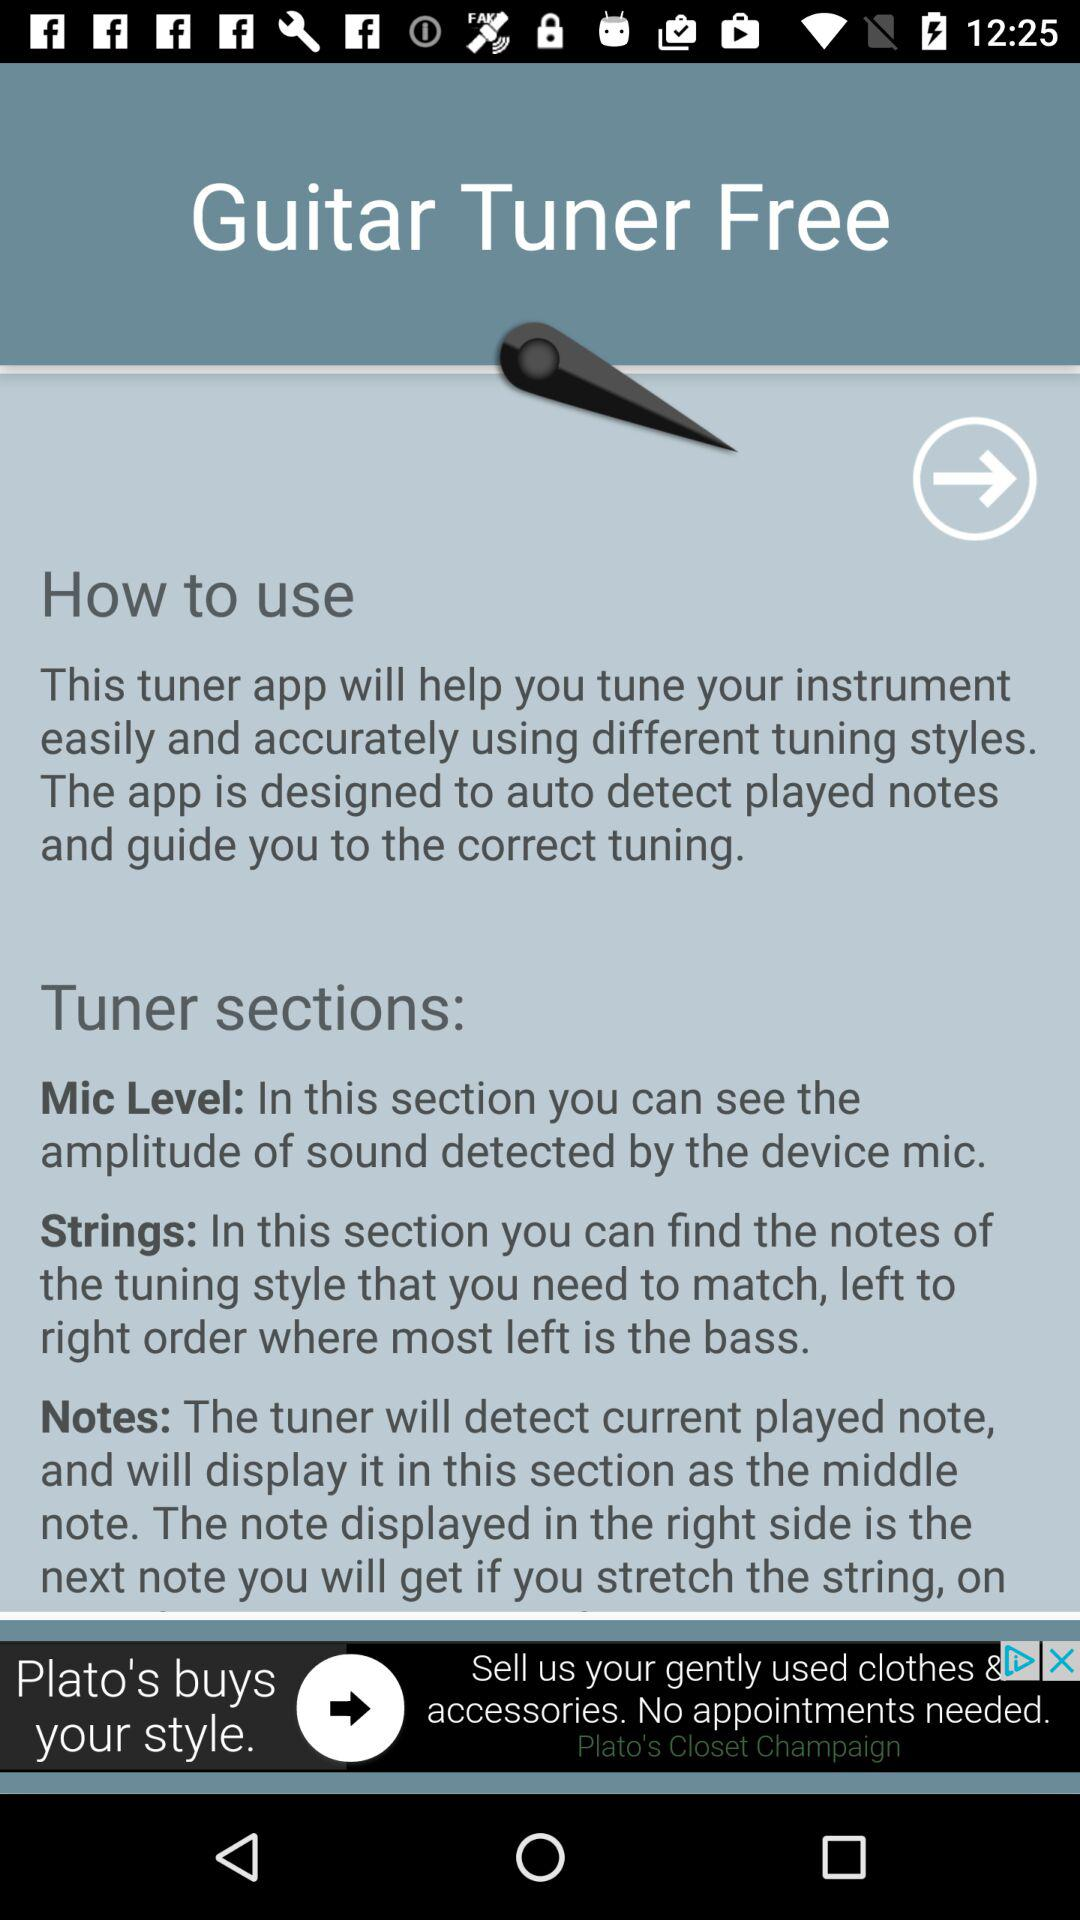How many sections does the tuner have?
Answer the question using a single word or phrase. 3 